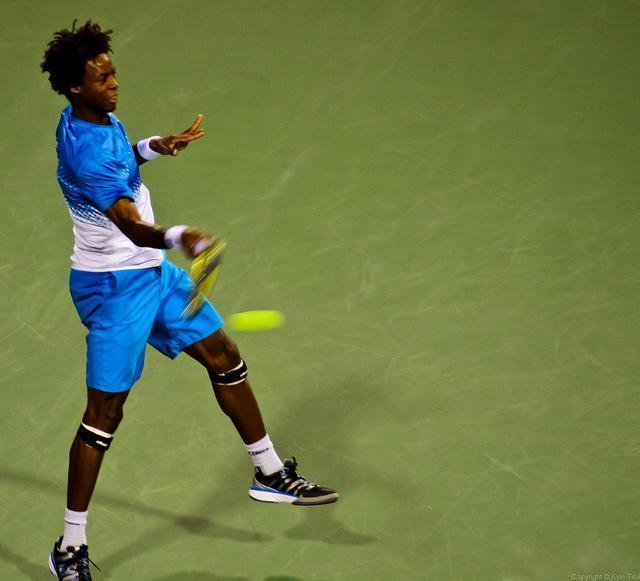How many people are there?
Give a very brief answer. 1. How many orange slices can you see?
Give a very brief answer. 0. 